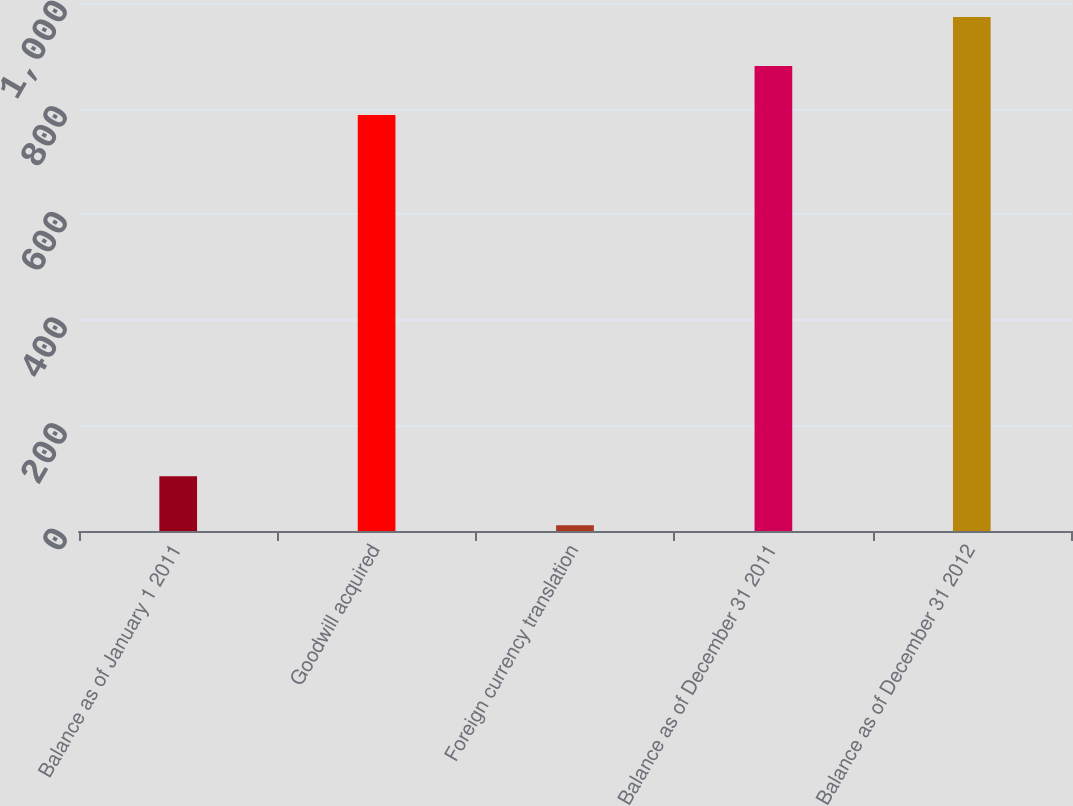Convert chart. <chart><loc_0><loc_0><loc_500><loc_500><bar_chart><fcel>Balance as of January 1 2011<fcel>Goodwill acquired<fcel>Foreign currency translation<fcel>Balance as of December 31 2011<fcel>Balance as of December 31 2012<nl><fcel>103.7<fcel>788<fcel>11<fcel>880.7<fcel>973.4<nl></chart> 